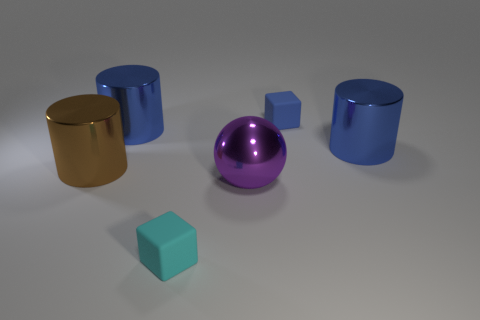Does the large brown object have the same material as the big purple ball?
Give a very brief answer. Yes. How many other things are the same material as the small blue cube?
Provide a succinct answer. 1. Are there more tiny blue matte objects than big blue metallic spheres?
Provide a succinct answer. Yes. Does the matte thing that is in front of the big brown metal cylinder have the same shape as the small blue object?
Your answer should be very brief. Yes. Are there fewer large metal objects than things?
Provide a succinct answer. Yes. What is the material of the brown thing that is the same size as the purple sphere?
Give a very brief answer. Metal. Is the number of brown cylinders that are behind the metal ball less than the number of large brown metal cylinders?
Ensure brevity in your answer.  No. How many tiny yellow metal balls are there?
Your answer should be compact. 0. The brown object to the left of the small matte thing that is in front of the big purple metal sphere is what shape?
Provide a short and direct response. Cylinder. There is a large metal sphere; how many cyan matte blocks are on the right side of it?
Ensure brevity in your answer.  0. 